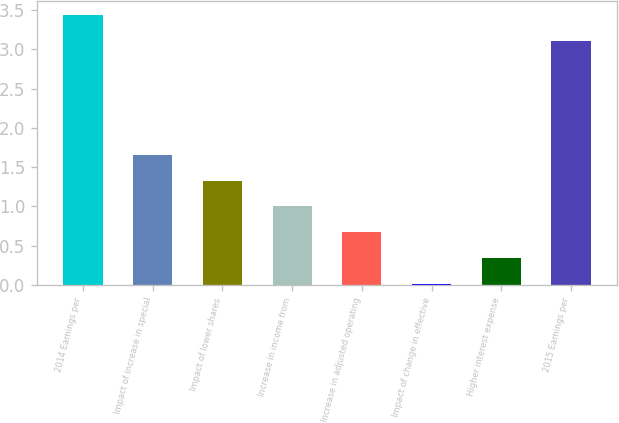<chart> <loc_0><loc_0><loc_500><loc_500><bar_chart><fcel>2014 Earnings per<fcel>Impact of increase in special<fcel>Impact of lower shares<fcel>Increase in income from<fcel>Increase in adjusted operating<fcel>Impact of change in effective<fcel>Higher interest expense<fcel>2015 Earnings per<nl><fcel>3.44<fcel>1.66<fcel>1.33<fcel>1<fcel>0.67<fcel>0.01<fcel>0.34<fcel>3.11<nl></chart> 